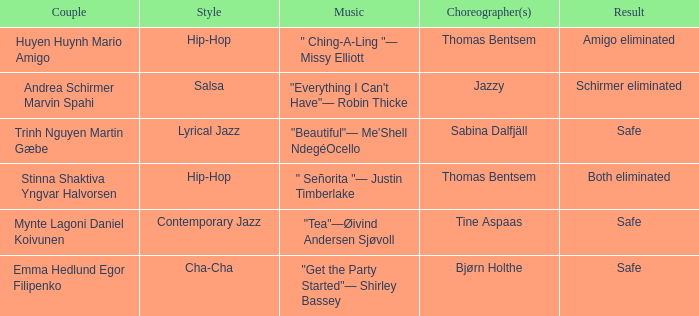Which twosome had a safe consequence and a lyrical jazz fashion? Trinh Nguyen Martin Gæbe. Help me parse the entirety of this table. {'header': ['Couple', 'Style', 'Music', 'Choreographer(s)', 'Result'], 'rows': [['Huyen Huynh Mario Amigo', 'Hip-Hop', '" Ching-A-Ling "— Missy Elliott', 'Thomas Bentsem', 'Amigo eliminated'], ['Andrea Schirmer Marvin Spahi', 'Salsa', '"Everything I Can\'t Have"— Robin Thicke', 'Jazzy', 'Schirmer eliminated'], ['Trinh Nguyen Martin Gæbe', 'Lyrical Jazz', '"Beautiful"— Me\'Shell NdegéOcello', 'Sabina Dalfjäll', 'Safe'], ['Stinna Shaktiva Yngvar Halvorsen', 'Hip-Hop', '" Señorita "— Justin Timberlake', 'Thomas Bentsem', 'Both eliminated'], ['Mynte Lagoni Daniel Koivunen', 'Contemporary Jazz', '"Tea"—Øivind Andersen Sjøvoll', 'Tine Aspaas', 'Safe'], ['Emma Hedlund Egor Filipenko', 'Cha-Cha', '"Get the Party Started"— Shirley Bassey', 'Bjørn Holthe', 'Safe']]} 